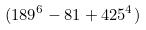Convert formula to latex. <formula><loc_0><loc_0><loc_500><loc_500>( 1 8 9 ^ { 6 } - 8 1 + 4 2 5 ^ { 4 } )</formula> 